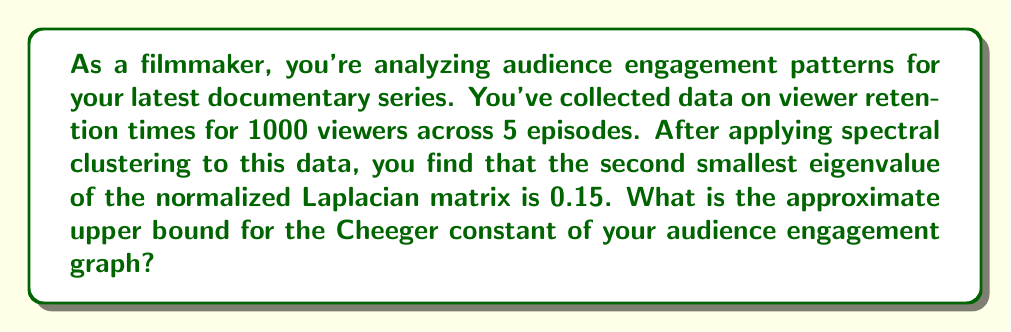Show me your answer to this math problem. To solve this problem, we'll use the relationship between the second smallest eigenvalue of the normalized Laplacian matrix (often denoted as $\lambda_2$) and the Cheeger constant (often denoted as $h_G$). This relationship is given by Cheeger's inequality:

$$\frac{\lambda_2}{2} \leq h_G \leq \sqrt{2\lambda_2}$$

We're given that $\lambda_2 = 0.15$. We're interested in the upper bound, which is the right side of the inequality:

$$h_G \leq \sqrt{2\lambda_2}$$

Let's calculate this:

1) First, multiply 0.15 by 2:
   $2 \times 0.15 = 0.3$

2) Then, take the square root:
   $\sqrt{0.3} \approx 0.5477$

Therefore, the upper bound for the Cheeger constant is approximately 0.5477.

This value gives us insight into the connectivity of our audience engagement graph. A lower Cheeger constant suggests more distinct clusters in viewer engagement patterns, while a higher value suggests more uniform engagement across episodes.
Answer: $\sqrt{2 \times 0.15} \approx 0.5477$ 